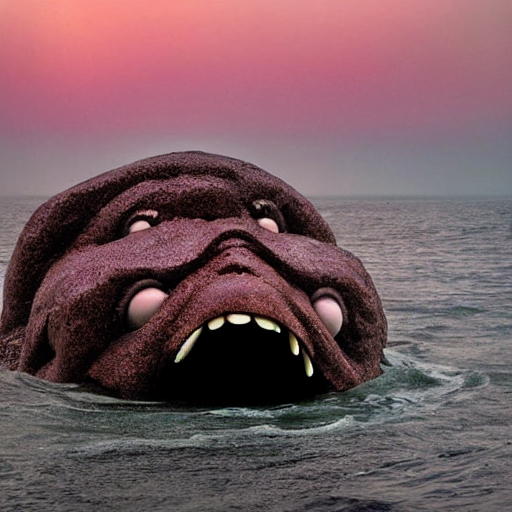Is the lighting weak in the image? The lighting in the image does create a subdued atmosphere. The background suggests it's either dawn or dusk, as the sky has shades of pink and purple that usually occur when the sun is low on the horizon. This soft illumination emphasizes the contours and the texture of the unusual entity emerging from the water without casting harsh shadows, giving the scene a tranquil yet mysterious ambiance. 